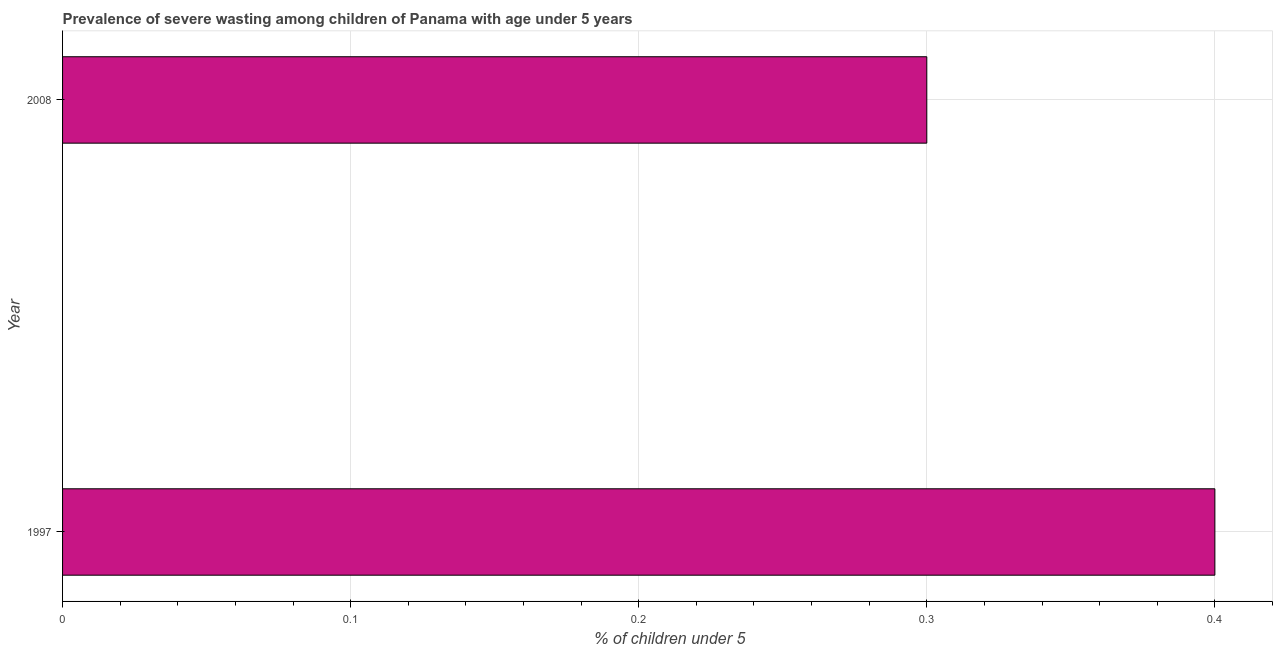Does the graph contain grids?
Your answer should be very brief. Yes. What is the title of the graph?
Keep it short and to the point. Prevalence of severe wasting among children of Panama with age under 5 years. What is the label or title of the X-axis?
Your answer should be compact.  % of children under 5. What is the label or title of the Y-axis?
Provide a short and direct response. Year. What is the prevalence of severe wasting in 2008?
Offer a very short reply. 0.3. Across all years, what is the maximum prevalence of severe wasting?
Make the answer very short. 0.4. Across all years, what is the minimum prevalence of severe wasting?
Ensure brevity in your answer.  0.3. In which year was the prevalence of severe wasting minimum?
Offer a terse response. 2008. What is the sum of the prevalence of severe wasting?
Your answer should be compact. 0.7. What is the average prevalence of severe wasting per year?
Offer a terse response. 0.35. What is the median prevalence of severe wasting?
Provide a short and direct response. 0.35. In how many years, is the prevalence of severe wasting greater than 0.2 %?
Keep it short and to the point. 2. What is the ratio of the prevalence of severe wasting in 1997 to that in 2008?
Your answer should be compact. 1.33. Is the prevalence of severe wasting in 1997 less than that in 2008?
Ensure brevity in your answer.  No. In how many years, is the prevalence of severe wasting greater than the average prevalence of severe wasting taken over all years?
Your response must be concise. 1. Are the values on the major ticks of X-axis written in scientific E-notation?
Offer a terse response. No. What is the  % of children under 5 in 1997?
Make the answer very short. 0.4. What is the  % of children under 5 in 2008?
Your response must be concise. 0.3. What is the ratio of the  % of children under 5 in 1997 to that in 2008?
Offer a very short reply. 1.33. 